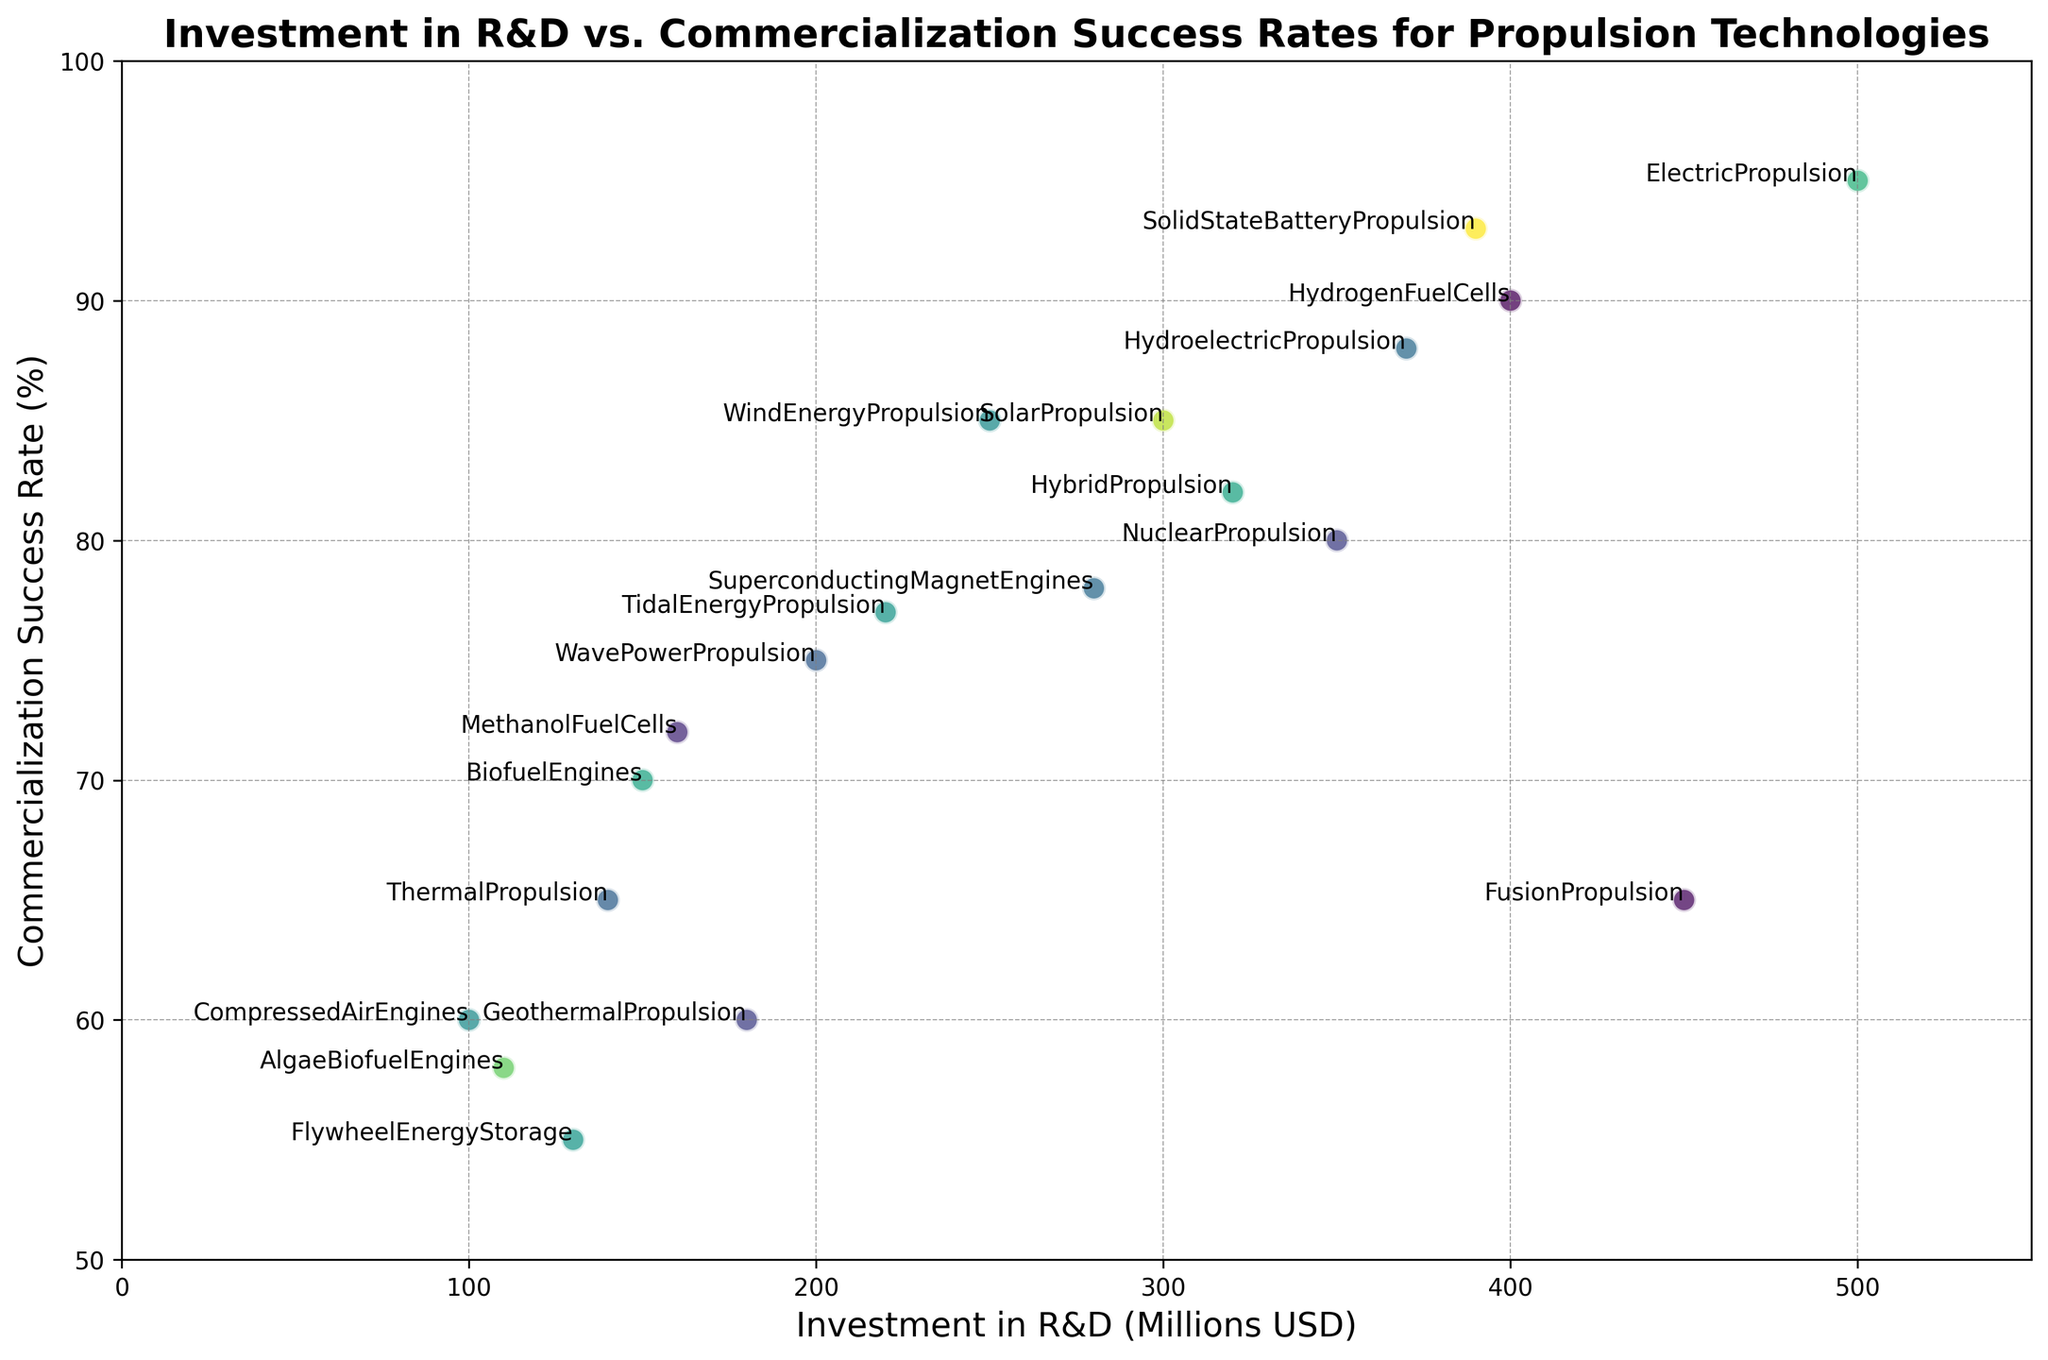What's the technology with the highest commercialization success rate? Look for the data point with the highest value on the y-axis (Commercialization Success Rate). In this case, it’s the data point at 95%.
Answer: Electric Propulsion Which technology has the lowest R&D investment? Identify the data point with the lowest value on the x-axis (Investment in R&D). The lowest investment value is 100 million USD.
Answer: Compressed Air Engines What’s the average investment in R&D across all technologies? Sum all the investments in R&D and divide by the number of technologies. The total investment is (300 + 150 + 400 + 500 + 350 + 100 + 200 + 450 + 250 + 180 + 220 + 320 + 130 + 280 + 140 + 160 + 370 + 110 + 390), which equals 5,900 million USD. Dividing by 19 (the number of technologies) gives an average investment: 5,900/19 ≈ 310.53 million USD.
Answer: 310.53 million USD Which two technologies have the same commercialization success rate, and what is that rate? Look for repeated values on the y-axis. Both Solar Propulsion and Wind Energy Propulsion are at 85%.
Answer: Solar Propulsion and Wind Energy Propulsion, 85% Which technology has a higher commercialization success rate: Biofuel Engines or Methanol Fuel Cells? Compare the y-values for Biofuel Engines (70%) and Methanol Fuel Cells (72%).
Answer: Methanol Fuel Cells What is the range of commercialization success rates across all technologies? Determine the highest and lowest values on the y-axis. The highest is 95% and the lowest is 55%, so the range is 95% - 55% = 40%.
Answer: 40% How does the R&D investment for Hydrogen Fuel Cells compare to that for Nuclear Propulsion? Compare the x-values: Hydrogen Fuel Cells is at 400 million USD, and Nuclear Propulsion is at 350 million USD.
Answer: Hydrogen Fuel Cells has a higher investment Which technology has the closest commercialization success rate to the average commercialization success rate of all technologies? Calculate the average success rate and find the closest value. The average is found by summing all the success rates (85 + 70 + 90 + 95 + 80 + 60 + 75 + 65 + 85 + 60 + 77 + 82 + 55 + 78 + 65 + 72 + 88 + 58 + 93) which equals 1418, divided by the 19 technologies: 1418/19 ≈ 74.63%. The closest success rate is 75%.
Answer: Wave Power Propulsion Which technology with an R&D investment under 200 million USD has the highest commercialization success rate? Filter technologies with investment less than 200 million USD and compare their success rates: Compressed Air Engines (60%), Geothermal Propulsion (60%), Algae Biofuel Engines (58%), Methanol Fuel Cells (72%). The highest success rate is 72%.
Answer: Methanol Fuel Cells 